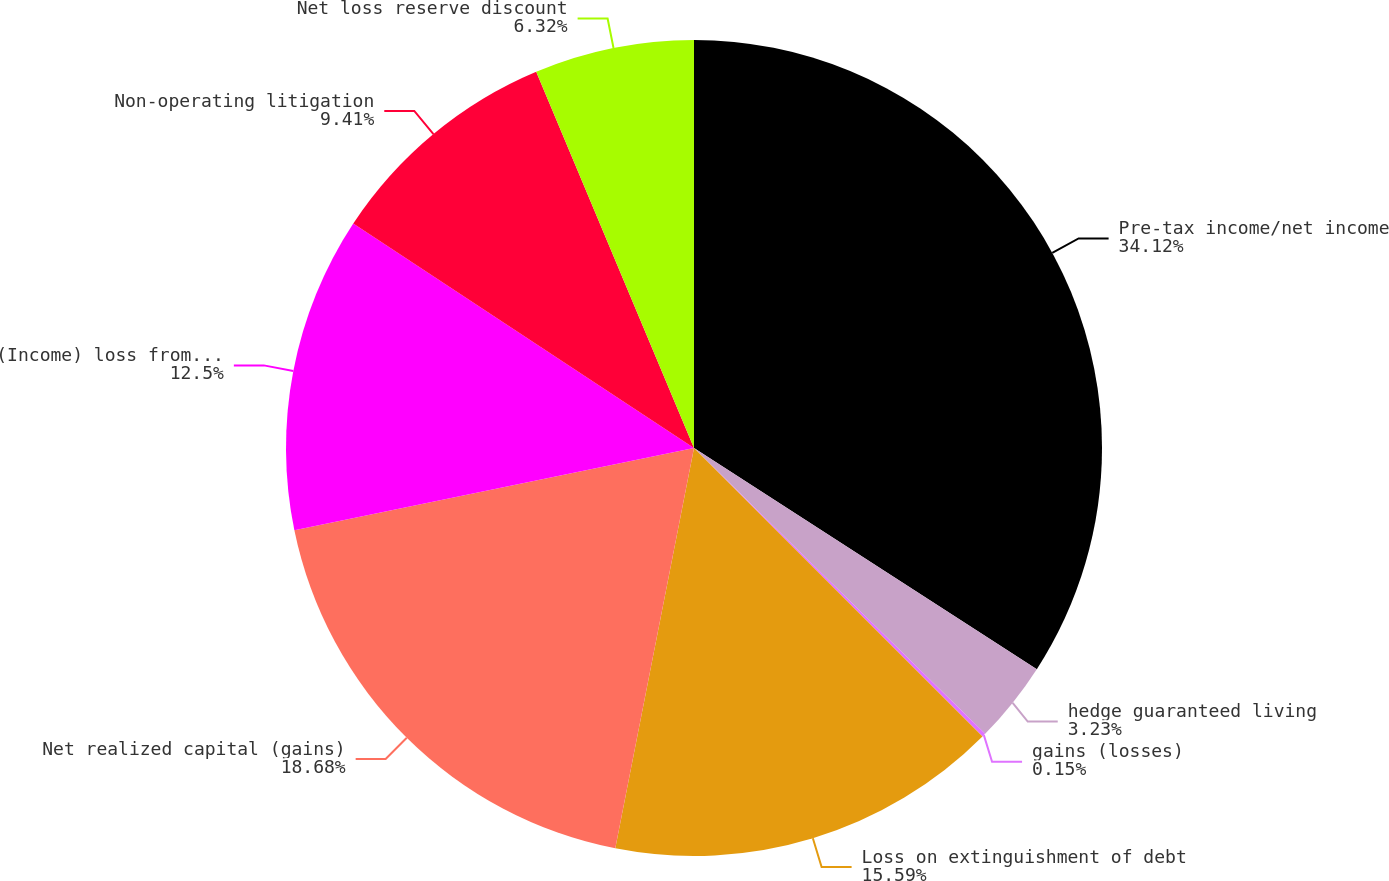Convert chart to OTSL. <chart><loc_0><loc_0><loc_500><loc_500><pie_chart><fcel>Pre-tax income/net income<fcel>hedge guaranteed living<fcel>gains (losses)<fcel>Loss on extinguishment of debt<fcel>Net realized capital (gains)<fcel>(Income) loss from divested<fcel>Non-operating litigation<fcel>Net loss reserve discount<nl><fcel>34.12%<fcel>3.23%<fcel>0.15%<fcel>15.59%<fcel>18.68%<fcel>12.5%<fcel>9.41%<fcel>6.32%<nl></chart> 